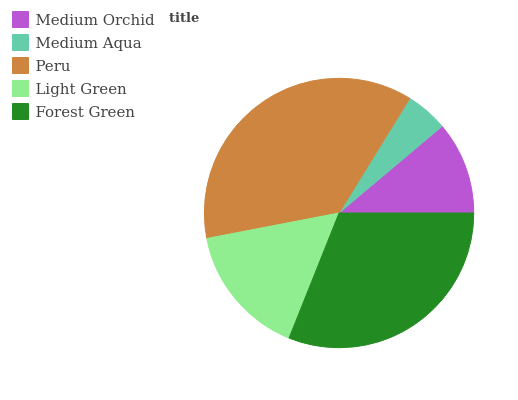Is Medium Aqua the minimum?
Answer yes or no. Yes. Is Peru the maximum?
Answer yes or no. Yes. Is Peru the minimum?
Answer yes or no. No. Is Medium Aqua the maximum?
Answer yes or no. No. Is Peru greater than Medium Aqua?
Answer yes or no. Yes. Is Medium Aqua less than Peru?
Answer yes or no. Yes. Is Medium Aqua greater than Peru?
Answer yes or no. No. Is Peru less than Medium Aqua?
Answer yes or no. No. Is Light Green the high median?
Answer yes or no. Yes. Is Light Green the low median?
Answer yes or no. Yes. Is Medium Orchid the high median?
Answer yes or no. No. Is Peru the low median?
Answer yes or no. No. 